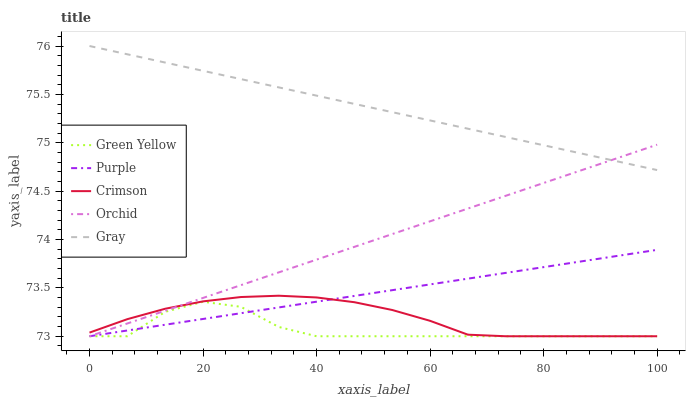Does Green Yellow have the minimum area under the curve?
Answer yes or no. Yes. Does Gray have the maximum area under the curve?
Answer yes or no. Yes. Does Crimson have the minimum area under the curve?
Answer yes or no. No. Does Crimson have the maximum area under the curve?
Answer yes or no. No. Is Purple the smoothest?
Answer yes or no. Yes. Is Green Yellow the roughest?
Answer yes or no. Yes. Is Crimson the smoothest?
Answer yes or no. No. Is Crimson the roughest?
Answer yes or no. No. Does Purple have the lowest value?
Answer yes or no. Yes. Does Gray have the lowest value?
Answer yes or no. No. Does Gray have the highest value?
Answer yes or no. Yes. Does Crimson have the highest value?
Answer yes or no. No. Is Crimson less than Gray?
Answer yes or no. Yes. Is Gray greater than Purple?
Answer yes or no. Yes. Does Green Yellow intersect Orchid?
Answer yes or no. Yes. Is Green Yellow less than Orchid?
Answer yes or no. No. Is Green Yellow greater than Orchid?
Answer yes or no. No. Does Crimson intersect Gray?
Answer yes or no. No. 